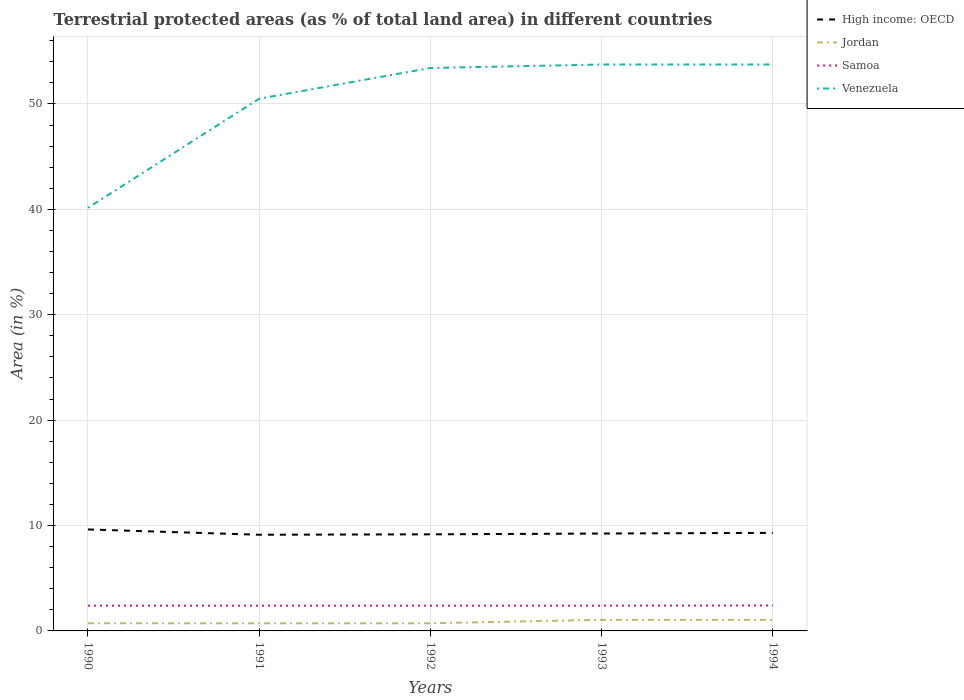How many different coloured lines are there?
Your answer should be compact. 4. Does the line corresponding to High income: OECD intersect with the line corresponding to Jordan?
Keep it short and to the point. No. Across all years, what is the maximum percentage of terrestrial protected land in High income: OECD?
Your response must be concise. 9.13. What is the total percentage of terrestrial protected land in Venezuela in the graph?
Make the answer very short. -13.6. What is the difference between the highest and the second highest percentage of terrestrial protected land in High income: OECD?
Provide a succinct answer. 0.5. What is the difference between the highest and the lowest percentage of terrestrial protected land in Jordan?
Your response must be concise. 2. Is the percentage of terrestrial protected land in High income: OECD strictly greater than the percentage of terrestrial protected land in Venezuela over the years?
Make the answer very short. Yes. How many lines are there?
Your response must be concise. 4. Are the values on the major ticks of Y-axis written in scientific E-notation?
Offer a terse response. No. Does the graph contain any zero values?
Your response must be concise. No. Does the graph contain grids?
Make the answer very short. Yes. What is the title of the graph?
Provide a succinct answer. Terrestrial protected areas (as % of total land area) in different countries. What is the label or title of the X-axis?
Provide a short and direct response. Years. What is the label or title of the Y-axis?
Provide a short and direct response. Area (in %). What is the Area (in %) of High income: OECD in 1990?
Provide a succinct answer. 9.63. What is the Area (in %) of Jordan in 1990?
Your response must be concise. 0.73. What is the Area (in %) in Samoa in 1990?
Give a very brief answer. 2.4. What is the Area (in %) of Venezuela in 1990?
Keep it short and to the point. 40.15. What is the Area (in %) of High income: OECD in 1991?
Your response must be concise. 9.13. What is the Area (in %) of Jordan in 1991?
Your answer should be compact. 0.73. What is the Area (in %) in Samoa in 1991?
Your answer should be compact. 2.4. What is the Area (in %) in Venezuela in 1991?
Provide a succinct answer. 50.5. What is the Area (in %) of High income: OECD in 1992?
Your response must be concise. 9.16. What is the Area (in %) in Jordan in 1992?
Make the answer very short. 0.73. What is the Area (in %) of Samoa in 1992?
Ensure brevity in your answer.  2.4. What is the Area (in %) in Venezuela in 1992?
Provide a succinct answer. 53.42. What is the Area (in %) of High income: OECD in 1993?
Provide a succinct answer. 9.24. What is the Area (in %) in Jordan in 1993?
Provide a short and direct response. 1.05. What is the Area (in %) of Samoa in 1993?
Your answer should be compact. 2.4. What is the Area (in %) in Venezuela in 1993?
Ensure brevity in your answer.  53.75. What is the Area (in %) of High income: OECD in 1994?
Your answer should be very brief. 9.3. What is the Area (in %) of Jordan in 1994?
Give a very brief answer. 1.05. What is the Area (in %) of Samoa in 1994?
Provide a succinct answer. 2.42. What is the Area (in %) of Venezuela in 1994?
Provide a short and direct response. 53.75. Across all years, what is the maximum Area (in %) of High income: OECD?
Ensure brevity in your answer.  9.63. Across all years, what is the maximum Area (in %) of Jordan?
Ensure brevity in your answer.  1.05. Across all years, what is the maximum Area (in %) in Samoa?
Your response must be concise. 2.42. Across all years, what is the maximum Area (in %) in Venezuela?
Provide a succinct answer. 53.75. Across all years, what is the minimum Area (in %) of High income: OECD?
Give a very brief answer. 9.13. Across all years, what is the minimum Area (in %) of Jordan?
Your answer should be compact. 0.73. Across all years, what is the minimum Area (in %) of Samoa?
Your response must be concise. 2.4. Across all years, what is the minimum Area (in %) of Venezuela?
Your answer should be very brief. 40.15. What is the total Area (in %) of High income: OECD in the graph?
Ensure brevity in your answer.  46.47. What is the total Area (in %) in Jordan in the graph?
Provide a succinct answer. 4.29. What is the total Area (in %) in Samoa in the graph?
Make the answer very short. 12. What is the total Area (in %) in Venezuela in the graph?
Give a very brief answer. 251.56. What is the difference between the Area (in %) of High income: OECD in 1990 and that in 1991?
Offer a very short reply. 0.5. What is the difference between the Area (in %) in Jordan in 1990 and that in 1991?
Your answer should be very brief. 0. What is the difference between the Area (in %) in Samoa in 1990 and that in 1991?
Ensure brevity in your answer.  0. What is the difference between the Area (in %) of Venezuela in 1990 and that in 1991?
Offer a very short reply. -10.36. What is the difference between the Area (in %) of High income: OECD in 1990 and that in 1992?
Your response must be concise. 0.46. What is the difference between the Area (in %) of Jordan in 1990 and that in 1992?
Make the answer very short. 0. What is the difference between the Area (in %) of Samoa in 1990 and that in 1992?
Your answer should be compact. 0. What is the difference between the Area (in %) of Venezuela in 1990 and that in 1992?
Make the answer very short. -13.27. What is the difference between the Area (in %) of High income: OECD in 1990 and that in 1993?
Offer a very short reply. 0.39. What is the difference between the Area (in %) of Jordan in 1990 and that in 1993?
Give a very brief answer. -0.33. What is the difference between the Area (in %) in Venezuela in 1990 and that in 1993?
Give a very brief answer. -13.6. What is the difference between the Area (in %) in High income: OECD in 1990 and that in 1994?
Make the answer very short. 0.33. What is the difference between the Area (in %) of Jordan in 1990 and that in 1994?
Provide a short and direct response. -0.33. What is the difference between the Area (in %) in Samoa in 1990 and that in 1994?
Make the answer very short. -0.02. What is the difference between the Area (in %) in Venezuela in 1990 and that in 1994?
Offer a terse response. -13.6. What is the difference between the Area (in %) in High income: OECD in 1991 and that in 1992?
Provide a succinct answer. -0.04. What is the difference between the Area (in %) of Jordan in 1991 and that in 1992?
Your answer should be compact. 0. What is the difference between the Area (in %) in Venezuela in 1991 and that in 1992?
Give a very brief answer. -2.92. What is the difference between the Area (in %) in High income: OECD in 1991 and that in 1993?
Keep it short and to the point. -0.12. What is the difference between the Area (in %) of Jordan in 1991 and that in 1993?
Offer a very short reply. -0.33. What is the difference between the Area (in %) in Samoa in 1991 and that in 1993?
Your answer should be very brief. 0. What is the difference between the Area (in %) in Venezuela in 1991 and that in 1993?
Ensure brevity in your answer.  -3.25. What is the difference between the Area (in %) in High income: OECD in 1991 and that in 1994?
Offer a very short reply. -0.18. What is the difference between the Area (in %) of Jordan in 1991 and that in 1994?
Offer a very short reply. -0.33. What is the difference between the Area (in %) of Samoa in 1991 and that in 1994?
Your answer should be very brief. -0.02. What is the difference between the Area (in %) of Venezuela in 1991 and that in 1994?
Offer a very short reply. -3.25. What is the difference between the Area (in %) in High income: OECD in 1992 and that in 1993?
Ensure brevity in your answer.  -0.08. What is the difference between the Area (in %) of Jordan in 1992 and that in 1993?
Offer a very short reply. -0.33. What is the difference between the Area (in %) in Venezuela in 1992 and that in 1993?
Offer a very short reply. -0.33. What is the difference between the Area (in %) in High income: OECD in 1992 and that in 1994?
Your response must be concise. -0.14. What is the difference between the Area (in %) in Jordan in 1992 and that in 1994?
Make the answer very short. -0.33. What is the difference between the Area (in %) of Samoa in 1992 and that in 1994?
Give a very brief answer. -0.02. What is the difference between the Area (in %) in Venezuela in 1992 and that in 1994?
Your response must be concise. -0.33. What is the difference between the Area (in %) of High income: OECD in 1993 and that in 1994?
Offer a very short reply. -0.06. What is the difference between the Area (in %) in Samoa in 1993 and that in 1994?
Provide a succinct answer. -0.02. What is the difference between the Area (in %) of High income: OECD in 1990 and the Area (in %) of Jordan in 1991?
Your answer should be compact. 8.9. What is the difference between the Area (in %) in High income: OECD in 1990 and the Area (in %) in Samoa in 1991?
Your answer should be compact. 7.23. What is the difference between the Area (in %) in High income: OECD in 1990 and the Area (in %) in Venezuela in 1991?
Make the answer very short. -40.87. What is the difference between the Area (in %) in Jordan in 1990 and the Area (in %) in Samoa in 1991?
Provide a succinct answer. -1.67. What is the difference between the Area (in %) in Jordan in 1990 and the Area (in %) in Venezuela in 1991?
Your answer should be very brief. -49.77. What is the difference between the Area (in %) in Samoa in 1990 and the Area (in %) in Venezuela in 1991?
Offer a terse response. -48.11. What is the difference between the Area (in %) of High income: OECD in 1990 and the Area (in %) of Jordan in 1992?
Keep it short and to the point. 8.9. What is the difference between the Area (in %) of High income: OECD in 1990 and the Area (in %) of Samoa in 1992?
Provide a succinct answer. 7.23. What is the difference between the Area (in %) in High income: OECD in 1990 and the Area (in %) in Venezuela in 1992?
Keep it short and to the point. -43.79. What is the difference between the Area (in %) in Jordan in 1990 and the Area (in %) in Samoa in 1992?
Your answer should be very brief. -1.67. What is the difference between the Area (in %) in Jordan in 1990 and the Area (in %) in Venezuela in 1992?
Keep it short and to the point. -52.69. What is the difference between the Area (in %) in Samoa in 1990 and the Area (in %) in Venezuela in 1992?
Your response must be concise. -51.02. What is the difference between the Area (in %) in High income: OECD in 1990 and the Area (in %) in Jordan in 1993?
Your answer should be compact. 8.58. What is the difference between the Area (in %) in High income: OECD in 1990 and the Area (in %) in Samoa in 1993?
Provide a succinct answer. 7.23. What is the difference between the Area (in %) in High income: OECD in 1990 and the Area (in %) in Venezuela in 1993?
Give a very brief answer. -44.12. What is the difference between the Area (in %) of Jordan in 1990 and the Area (in %) of Samoa in 1993?
Offer a terse response. -1.67. What is the difference between the Area (in %) in Jordan in 1990 and the Area (in %) in Venezuela in 1993?
Keep it short and to the point. -53.02. What is the difference between the Area (in %) of Samoa in 1990 and the Area (in %) of Venezuela in 1993?
Offer a very short reply. -51.35. What is the difference between the Area (in %) in High income: OECD in 1990 and the Area (in %) in Jordan in 1994?
Provide a succinct answer. 8.58. What is the difference between the Area (in %) in High income: OECD in 1990 and the Area (in %) in Samoa in 1994?
Your response must be concise. 7.21. What is the difference between the Area (in %) in High income: OECD in 1990 and the Area (in %) in Venezuela in 1994?
Offer a terse response. -44.12. What is the difference between the Area (in %) of Jordan in 1990 and the Area (in %) of Samoa in 1994?
Keep it short and to the point. -1.69. What is the difference between the Area (in %) of Jordan in 1990 and the Area (in %) of Venezuela in 1994?
Give a very brief answer. -53.02. What is the difference between the Area (in %) of Samoa in 1990 and the Area (in %) of Venezuela in 1994?
Offer a very short reply. -51.35. What is the difference between the Area (in %) of High income: OECD in 1991 and the Area (in %) of Jordan in 1992?
Provide a succinct answer. 8.4. What is the difference between the Area (in %) of High income: OECD in 1991 and the Area (in %) of Samoa in 1992?
Keep it short and to the point. 6.73. What is the difference between the Area (in %) in High income: OECD in 1991 and the Area (in %) in Venezuela in 1992?
Offer a terse response. -44.29. What is the difference between the Area (in %) in Jordan in 1991 and the Area (in %) in Samoa in 1992?
Offer a very short reply. -1.67. What is the difference between the Area (in %) of Jordan in 1991 and the Area (in %) of Venezuela in 1992?
Make the answer very short. -52.69. What is the difference between the Area (in %) of Samoa in 1991 and the Area (in %) of Venezuela in 1992?
Your answer should be compact. -51.02. What is the difference between the Area (in %) of High income: OECD in 1991 and the Area (in %) of Jordan in 1993?
Offer a very short reply. 8.07. What is the difference between the Area (in %) of High income: OECD in 1991 and the Area (in %) of Samoa in 1993?
Provide a short and direct response. 6.73. What is the difference between the Area (in %) of High income: OECD in 1991 and the Area (in %) of Venezuela in 1993?
Your answer should be very brief. -44.62. What is the difference between the Area (in %) of Jordan in 1991 and the Area (in %) of Samoa in 1993?
Keep it short and to the point. -1.67. What is the difference between the Area (in %) of Jordan in 1991 and the Area (in %) of Venezuela in 1993?
Provide a succinct answer. -53.02. What is the difference between the Area (in %) in Samoa in 1991 and the Area (in %) in Venezuela in 1993?
Provide a short and direct response. -51.35. What is the difference between the Area (in %) of High income: OECD in 1991 and the Area (in %) of Jordan in 1994?
Your response must be concise. 8.07. What is the difference between the Area (in %) of High income: OECD in 1991 and the Area (in %) of Samoa in 1994?
Make the answer very short. 6.71. What is the difference between the Area (in %) in High income: OECD in 1991 and the Area (in %) in Venezuela in 1994?
Keep it short and to the point. -44.62. What is the difference between the Area (in %) of Jordan in 1991 and the Area (in %) of Samoa in 1994?
Your response must be concise. -1.69. What is the difference between the Area (in %) in Jordan in 1991 and the Area (in %) in Venezuela in 1994?
Ensure brevity in your answer.  -53.02. What is the difference between the Area (in %) of Samoa in 1991 and the Area (in %) of Venezuela in 1994?
Make the answer very short. -51.35. What is the difference between the Area (in %) of High income: OECD in 1992 and the Area (in %) of Jordan in 1993?
Your answer should be very brief. 8.11. What is the difference between the Area (in %) in High income: OECD in 1992 and the Area (in %) in Samoa in 1993?
Provide a succinct answer. 6.77. What is the difference between the Area (in %) in High income: OECD in 1992 and the Area (in %) in Venezuela in 1993?
Make the answer very short. -44.58. What is the difference between the Area (in %) of Jordan in 1992 and the Area (in %) of Samoa in 1993?
Ensure brevity in your answer.  -1.67. What is the difference between the Area (in %) in Jordan in 1992 and the Area (in %) in Venezuela in 1993?
Provide a succinct answer. -53.02. What is the difference between the Area (in %) in Samoa in 1992 and the Area (in %) in Venezuela in 1993?
Ensure brevity in your answer.  -51.35. What is the difference between the Area (in %) in High income: OECD in 1992 and the Area (in %) in Jordan in 1994?
Make the answer very short. 8.11. What is the difference between the Area (in %) of High income: OECD in 1992 and the Area (in %) of Samoa in 1994?
Give a very brief answer. 6.75. What is the difference between the Area (in %) in High income: OECD in 1992 and the Area (in %) in Venezuela in 1994?
Keep it short and to the point. -44.58. What is the difference between the Area (in %) in Jordan in 1992 and the Area (in %) in Samoa in 1994?
Ensure brevity in your answer.  -1.69. What is the difference between the Area (in %) in Jordan in 1992 and the Area (in %) in Venezuela in 1994?
Your answer should be very brief. -53.02. What is the difference between the Area (in %) in Samoa in 1992 and the Area (in %) in Venezuela in 1994?
Offer a terse response. -51.35. What is the difference between the Area (in %) of High income: OECD in 1993 and the Area (in %) of Jordan in 1994?
Provide a succinct answer. 8.19. What is the difference between the Area (in %) in High income: OECD in 1993 and the Area (in %) in Samoa in 1994?
Give a very brief answer. 6.82. What is the difference between the Area (in %) of High income: OECD in 1993 and the Area (in %) of Venezuela in 1994?
Keep it short and to the point. -44.5. What is the difference between the Area (in %) in Jordan in 1993 and the Area (in %) in Samoa in 1994?
Keep it short and to the point. -1.37. What is the difference between the Area (in %) in Jordan in 1993 and the Area (in %) in Venezuela in 1994?
Offer a very short reply. -52.69. What is the difference between the Area (in %) in Samoa in 1993 and the Area (in %) in Venezuela in 1994?
Give a very brief answer. -51.35. What is the average Area (in %) in High income: OECD per year?
Provide a short and direct response. 9.29. What is the average Area (in %) of Jordan per year?
Offer a very short reply. 0.86. What is the average Area (in %) in Samoa per year?
Ensure brevity in your answer.  2.4. What is the average Area (in %) of Venezuela per year?
Offer a terse response. 50.31. In the year 1990, what is the difference between the Area (in %) of High income: OECD and Area (in %) of Jordan?
Provide a succinct answer. 8.9. In the year 1990, what is the difference between the Area (in %) of High income: OECD and Area (in %) of Samoa?
Give a very brief answer. 7.23. In the year 1990, what is the difference between the Area (in %) of High income: OECD and Area (in %) of Venezuela?
Make the answer very short. -30.52. In the year 1990, what is the difference between the Area (in %) in Jordan and Area (in %) in Samoa?
Offer a very short reply. -1.67. In the year 1990, what is the difference between the Area (in %) of Jordan and Area (in %) of Venezuela?
Make the answer very short. -39.42. In the year 1990, what is the difference between the Area (in %) of Samoa and Area (in %) of Venezuela?
Provide a succinct answer. -37.75. In the year 1991, what is the difference between the Area (in %) in High income: OECD and Area (in %) in Jordan?
Provide a short and direct response. 8.4. In the year 1991, what is the difference between the Area (in %) in High income: OECD and Area (in %) in Samoa?
Make the answer very short. 6.73. In the year 1991, what is the difference between the Area (in %) of High income: OECD and Area (in %) of Venezuela?
Make the answer very short. -41.37. In the year 1991, what is the difference between the Area (in %) of Jordan and Area (in %) of Samoa?
Keep it short and to the point. -1.67. In the year 1991, what is the difference between the Area (in %) in Jordan and Area (in %) in Venezuela?
Your response must be concise. -49.77. In the year 1991, what is the difference between the Area (in %) of Samoa and Area (in %) of Venezuela?
Keep it short and to the point. -48.11. In the year 1992, what is the difference between the Area (in %) in High income: OECD and Area (in %) in Jordan?
Keep it short and to the point. 8.44. In the year 1992, what is the difference between the Area (in %) of High income: OECD and Area (in %) of Samoa?
Offer a terse response. 6.77. In the year 1992, what is the difference between the Area (in %) in High income: OECD and Area (in %) in Venezuela?
Provide a succinct answer. -44.25. In the year 1992, what is the difference between the Area (in %) in Jordan and Area (in %) in Samoa?
Offer a terse response. -1.67. In the year 1992, what is the difference between the Area (in %) of Jordan and Area (in %) of Venezuela?
Make the answer very short. -52.69. In the year 1992, what is the difference between the Area (in %) in Samoa and Area (in %) in Venezuela?
Give a very brief answer. -51.02. In the year 1993, what is the difference between the Area (in %) in High income: OECD and Area (in %) in Jordan?
Keep it short and to the point. 8.19. In the year 1993, what is the difference between the Area (in %) of High income: OECD and Area (in %) of Samoa?
Make the answer very short. 6.85. In the year 1993, what is the difference between the Area (in %) of High income: OECD and Area (in %) of Venezuela?
Give a very brief answer. -44.5. In the year 1993, what is the difference between the Area (in %) of Jordan and Area (in %) of Samoa?
Offer a very short reply. -1.34. In the year 1993, what is the difference between the Area (in %) in Jordan and Area (in %) in Venezuela?
Your response must be concise. -52.69. In the year 1993, what is the difference between the Area (in %) in Samoa and Area (in %) in Venezuela?
Your response must be concise. -51.35. In the year 1994, what is the difference between the Area (in %) of High income: OECD and Area (in %) of Jordan?
Ensure brevity in your answer.  8.25. In the year 1994, what is the difference between the Area (in %) of High income: OECD and Area (in %) of Samoa?
Offer a terse response. 6.88. In the year 1994, what is the difference between the Area (in %) of High income: OECD and Area (in %) of Venezuela?
Provide a succinct answer. -44.44. In the year 1994, what is the difference between the Area (in %) in Jordan and Area (in %) in Samoa?
Provide a succinct answer. -1.37. In the year 1994, what is the difference between the Area (in %) in Jordan and Area (in %) in Venezuela?
Your response must be concise. -52.69. In the year 1994, what is the difference between the Area (in %) of Samoa and Area (in %) of Venezuela?
Offer a very short reply. -51.33. What is the ratio of the Area (in %) of High income: OECD in 1990 to that in 1991?
Provide a succinct answer. 1.05. What is the ratio of the Area (in %) of Jordan in 1990 to that in 1991?
Ensure brevity in your answer.  1. What is the ratio of the Area (in %) in Samoa in 1990 to that in 1991?
Provide a succinct answer. 1. What is the ratio of the Area (in %) in Venezuela in 1990 to that in 1991?
Your answer should be compact. 0.79. What is the ratio of the Area (in %) of High income: OECD in 1990 to that in 1992?
Your answer should be very brief. 1.05. What is the ratio of the Area (in %) of Jordan in 1990 to that in 1992?
Your answer should be compact. 1. What is the ratio of the Area (in %) in Venezuela in 1990 to that in 1992?
Provide a short and direct response. 0.75. What is the ratio of the Area (in %) of High income: OECD in 1990 to that in 1993?
Offer a very short reply. 1.04. What is the ratio of the Area (in %) of Jordan in 1990 to that in 1993?
Your answer should be compact. 0.69. What is the ratio of the Area (in %) of Venezuela in 1990 to that in 1993?
Your answer should be compact. 0.75. What is the ratio of the Area (in %) in High income: OECD in 1990 to that in 1994?
Your response must be concise. 1.03. What is the ratio of the Area (in %) of Jordan in 1990 to that in 1994?
Offer a very short reply. 0.69. What is the ratio of the Area (in %) in Venezuela in 1990 to that in 1994?
Make the answer very short. 0.75. What is the ratio of the Area (in %) in Venezuela in 1991 to that in 1992?
Make the answer very short. 0.95. What is the ratio of the Area (in %) in High income: OECD in 1991 to that in 1993?
Offer a very short reply. 0.99. What is the ratio of the Area (in %) in Jordan in 1991 to that in 1993?
Make the answer very short. 0.69. What is the ratio of the Area (in %) of Venezuela in 1991 to that in 1993?
Provide a short and direct response. 0.94. What is the ratio of the Area (in %) in High income: OECD in 1991 to that in 1994?
Provide a succinct answer. 0.98. What is the ratio of the Area (in %) of Jordan in 1991 to that in 1994?
Ensure brevity in your answer.  0.69. What is the ratio of the Area (in %) of Samoa in 1991 to that in 1994?
Your answer should be compact. 0.99. What is the ratio of the Area (in %) of Venezuela in 1991 to that in 1994?
Provide a succinct answer. 0.94. What is the ratio of the Area (in %) of High income: OECD in 1992 to that in 1993?
Ensure brevity in your answer.  0.99. What is the ratio of the Area (in %) in Jordan in 1992 to that in 1993?
Offer a terse response. 0.69. What is the ratio of the Area (in %) of High income: OECD in 1992 to that in 1994?
Your answer should be very brief. 0.99. What is the ratio of the Area (in %) of Jordan in 1992 to that in 1994?
Make the answer very short. 0.69. What is the ratio of the Area (in %) of Samoa in 1992 to that in 1994?
Your response must be concise. 0.99. What is the ratio of the Area (in %) in High income: OECD in 1993 to that in 1994?
Your answer should be compact. 0.99. What is the ratio of the Area (in %) of Samoa in 1993 to that in 1994?
Make the answer very short. 0.99. What is the ratio of the Area (in %) of Venezuela in 1993 to that in 1994?
Your response must be concise. 1. What is the difference between the highest and the second highest Area (in %) in High income: OECD?
Your response must be concise. 0.33. What is the difference between the highest and the second highest Area (in %) in Jordan?
Make the answer very short. 0. What is the difference between the highest and the second highest Area (in %) in Samoa?
Provide a succinct answer. 0.02. What is the difference between the highest and the second highest Area (in %) in Venezuela?
Your response must be concise. 0. What is the difference between the highest and the lowest Area (in %) of High income: OECD?
Keep it short and to the point. 0.5. What is the difference between the highest and the lowest Area (in %) of Jordan?
Your response must be concise. 0.33. What is the difference between the highest and the lowest Area (in %) of Samoa?
Your answer should be very brief. 0.02. What is the difference between the highest and the lowest Area (in %) of Venezuela?
Give a very brief answer. 13.6. 